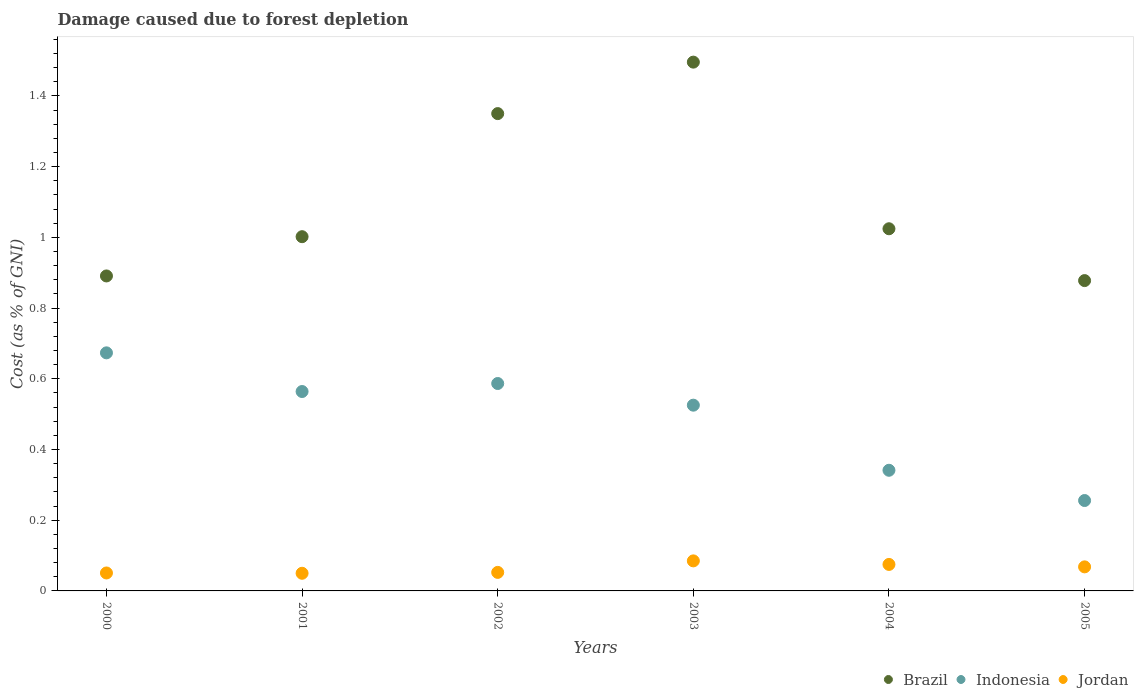How many different coloured dotlines are there?
Keep it short and to the point. 3. What is the cost of damage caused due to forest depletion in Jordan in 2005?
Your answer should be compact. 0.07. Across all years, what is the maximum cost of damage caused due to forest depletion in Jordan?
Provide a short and direct response. 0.08. Across all years, what is the minimum cost of damage caused due to forest depletion in Jordan?
Give a very brief answer. 0.05. In which year was the cost of damage caused due to forest depletion in Indonesia minimum?
Give a very brief answer. 2005. What is the total cost of damage caused due to forest depletion in Brazil in the graph?
Your answer should be very brief. 6.64. What is the difference between the cost of damage caused due to forest depletion in Jordan in 2004 and that in 2005?
Offer a terse response. 0.01. What is the difference between the cost of damage caused due to forest depletion in Indonesia in 2003 and the cost of damage caused due to forest depletion in Jordan in 2005?
Provide a short and direct response. 0.46. What is the average cost of damage caused due to forest depletion in Jordan per year?
Make the answer very short. 0.06. In the year 2002, what is the difference between the cost of damage caused due to forest depletion in Brazil and cost of damage caused due to forest depletion in Jordan?
Give a very brief answer. 1.3. In how many years, is the cost of damage caused due to forest depletion in Jordan greater than 0.24000000000000002 %?
Provide a short and direct response. 0. What is the ratio of the cost of damage caused due to forest depletion in Brazil in 2000 to that in 2004?
Your answer should be very brief. 0.87. Is the cost of damage caused due to forest depletion in Brazil in 2000 less than that in 2004?
Provide a succinct answer. Yes. Is the difference between the cost of damage caused due to forest depletion in Brazil in 2001 and 2002 greater than the difference between the cost of damage caused due to forest depletion in Jordan in 2001 and 2002?
Provide a succinct answer. No. What is the difference between the highest and the second highest cost of damage caused due to forest depletion in Brazil?
Provide a short and direct response. 0.15. What is the difference between the highest and the lowest cost of damage caused due to forest depletion in Brazil?
Offer a terse response. 0.62. Is it the case that in every year, the sum of the cost of damage caused due to forest depletion in Brazil and cost of damage caused due to forest depletion in Indonesia  is greater than the cost of damage caused due to forest depletion in Jordan?
Offer a terse response. Yes. How many dotlines are there?
Provide a succinct answer. 3. Are the values on the major ticks of Y-axis written in scientific E-notation?
Keep it short and to the point. No. What is the title of the graph?
Offer a terse response. Damage caused due to forest depletion. Does "Small states" appear as one of the legend labels in the graph?
Offer a terse response. No. What is the label or title of the X-axis?
Keep it short and to the point. Years. What is the label or title of the Y-axis?
Offer a very short reply. Cost (as % of GNI). What is the Cost (as % of GNI) of Brazil in 2000?
Your answer should be compact. 0.89. What is the Cost (as % of GNI) in Indonesia in 2000?
Your response must be concise. 0.67. What is the Cost (as % of GNI) of Jordan in 2000?
Your answer should be compact. 0.05. What is the Cost (as % of GNI) of Brazil in 2001?
Ensure brevity in your answer.  1. What is the Cost (as % of GNI) in Indonesia in 2001?
Offer a very short reply. 0.56. What is the Cost (as % of GNI) in Jordan in 2001?
Give a very brief answer. 0.05. What is the Cost (as % of GNI) in Brazil in 2002?
Ensure brevity in your answer.  1.35. What is the Cost (as % of GNI) in Indonesia in 2002?
Offer a very short reply. 0.59. What is the Cost (as % of GNI) of Jordan in 2002?
Offer a terse response. 0.05. What is the Cost (as % of GNI) in Brazil in 2003?
Offer a terse response. 1.5. What is the Cost (as % of GNI) of Indonesia in 2003?
Ensure brevity in your answer.  0.53. What is the Cost (as % of GNI) of Jordan in 2003?
Provide a short and direct response. 0.08. What is the Cost (as % of GNI) in Brazil in 2004?
Make the answer very short. 1.02. What is the Cost (as % of GNI) of Indonesia in 2004?
Make the answer very short. 0.34. What is the Cost (as % of GNI) of Jordan in 2004?
Offer a very short reply. 0.07. What is the Cost (as % of GNI) in Brazil in 2005?
Keep it short and to the point. 0.88. What is the Cost (as % of GNI) of Indonesia in 2005?
Ensure brevity in your answer.  0.26. What is the Cost (as % of GNI) of Jordan in 2005?
Give a very brief answer. 0.07. Across all years, what is the maximum Cost (as % of GNI) of Brazil?
Provide a succinct answer. 1.5. Across all years, what is the maximum Cost (as % of GNI) in Indonesia?
Your answer should be very brief. 0.67. Across all years, what is the maximum Cost (as % of GNI) in Jordan?
Provide a succinct answer. 0.08. Across all years, what is the minimum Cost (as % of GNI) of Brazil?
Provide a short and direct response. 0.88. Across all years, what is the minimum Cost (as % of GNI) in Indonesia?
Offer a very short reply. 0.26. Across all years, what is the minimum Cost (as % of GNI) of Jordan?
Provide a short and direct response. 0.05. What is the total Cost (as % of GNI) of Brazil in the graph?
Your response must be concise. 6.64. What is the total Cost (as % of GNI) of Indonesia in the graph?
Give a very brief answer. 2.95. What is the total Cost (as % of GNI) in Jordan in the graph?
Make the answer very short. 0.38. What is the difference between the Cost (as % of GNI) of Brazil in 2000 and that in 2001?
Keep it short and to the point. -0.11. What is the difference between the Cost (as % of GNI) of Indonesia in 2000 and that in 2001?
Offer a very short reply. 0.11. What is the difference between the Cost (as % of GNI) of Jordan in 2000 and that in 2001?
Offer a very short reply. 0. What is the difference between the Cost (as % of GNI) of Brazil in 2000 and that in 2002?
Offer a very short reply. -0.46. What is the difference between the Cost (as % of GNI) in Indonesia in 2000 and that in 2002?
Your response must be concise. 0.09. What is the difference between the Cost (as % of GNI) of Jordan in 2000 and that in 2002?
Give a very brief answer. -0. What is the difference between the Cost (as % of GNI) in Brazil in 2000 and that in 2003?
Your answer should be very brief. -0.6. What is the difference between the Cost (as % of GNI) of Indonesia in 2000 and that in 2003?
Your answer should be very brief. 0.15. What is the difference between the Cost (as % of GNI) of Jordan in 2000 and that in 2003?
Your answer should be compact. -0.03. What is the difference between the Cost (as % of GNI) of Brazil in 2000 and that in 2004?
Provide a short and direct response. -0.13. What is the difference between the Cost (as % of GNI) in Indonesia in 2000 and that in 2004?
Give a very brief answer. 0.33. What is the difference between the Cost (as % of GNI) of Jordan in 2000 and that in 2004?
Give a very brief answer. -0.02. What is the difference between the Cost (as % of GNI) of Brazil in 2000 and that in 2005?
Make the answer very short. 0.01. What is the difference between the Cost (as % of GNI) of Indonesia in 2000 and that in 2005?
Your answer should be compact. 0.42. What is the difference between the Cost (as % of GNI) of Jordan in 2000 and that in 2005?
Your response must be concise. -0.02. What is the difference between the Cost (as % of GNI) in Brazil in 2001 and that in 2002?
Make the answer very short. -0.35. What is the difference between the Cost (as % of GNI) of Indonesia in 2001 and that in 2002?
Offer a very short reply. -0.02. What is the difference between the Cost (as % of GNI) of Jordan in 2001 and that in 2002?
Give a very brief answer. -0. What is the difference between the Cost (as % of GNI) in Brazil in 2001 and that in 2003?
Offer a terse response. -0.49. What is the difference between the Cost (as % of GNI) of Indonesia in 2001 and that in 2003?
Your answer should be very brief. 0.04. What is the difference between the Cost (as % of GNI) in Jordan in 2001 and that in 2003?
Offer a very short reply. -0.04. What is the difference between the Cost (as % of GNI) of Brazil in 2001 and that in 2004?
Offer a terse response. -0.02. What is the difference between the Cost (as % of GNI) of Indonesia in 2001 and that in 2004?
Provide a succinct answer. 0.22. What is the difference between the Cost (as % of GNI) in Jordan in 2001 and that in 2004?
Provide a short and direct response. -0.03. What is the difference between the Cost (as % of GNI) of Brazil in 2001 and that in 2005?
Your answer should be very brief. 0.12. What is the difference between the Cost (as % of GNI) in Indonesia in 2001 and that in 2005?
Make the answer very short. 0.31. What is the difference between the Cost (as % of GNI) in Jordan in 2001 and that in 2005?
Ensure brevity in your answer.  -0.02. What is the difference between the Cost (as % of GNI) in Brazil in 2002 and that in 2003?
Give a very brief answer. -0.15. What is the difference between the Cost (as % of GNI) of Indonesia in 2002 and that in 2003?
Provide a short and direct response. 0.06. What is the difference between the Cost (as % of GNI) in Jordan in 2002 and that in 2003?
Your response must be concise. -0.03. What is the difference between the Cost (as % of GNI) of Brazil in 2002 and that in 2004?
Give a very brief answer. 0.33. What is the difference between the Cost (as % of GNI) of Indonesia in 2002 and that in 2004?
Offer a very short reply. 0.25. What is the difference between the Cost (as % of GNI) of Jordan in 2002 and that in 2004?
Make the answer very short. -0.02. What is the difference between the Cost (as % of GNI) in Brazil in 2002 and that in 2005?
Offer a terse response. 0.47. What is the difference between the Cost (as % of GNI) in Indonesia in 2002 and that in 2005?
Ensure brevity in your answer.  0.33. What is the difference between the Cost (as % of GNI) in Jordan in 2002 and that in 2005?
Your response must be concise. -0.02. What is the difference between the Cost (as % of GNI) in Brazil in 2003 and that in 2004?
Provide a succinct answer. 0.47. What is the difference between the Cost (as % of GNI) of Indonesia in 2003 and that in 2004?
Make the answer very short. 0.18. What is the difference between the Cost (as % of GNI) in Jordan in 2003 and that in 2004?
Ensure brevity in your answer.  0.01. What is the difference between the Cost (as % of GNI) of Brazil in 2003 and that in 2005?
Make the answer very short. 0.62. What is the difference between the Cost (as % of GNI) in Indonesia in 2003 and that in 2005?
Your answer should be compact. 0.27. What is the difference between the Cost (as % of GNI) in Jordan in 2003 and that in 2005?
Provide a succinct answer. 0.02. What is the difference between the Cost (as % of GNI) of Brazil in 2004 and that in 2005?
Ensure brevity in your answer.  0.15. What is the difference between the Cost (as % of GNI) in Indonesia in 2004 and that in 2005?
Keep it short and to the point. 0.09. What is the difference between the Cost (as % of GNI) in Jordan in 2004 and that in 2005?
Provide a succinct answer. 0.01. What is the difference between the Cost (as % of GNI) in Brazil in 2000 and the Cost (as % of GNI) in Indonesia in 2001?
Your response must be concise. 0.33. What is the difference between the Cost (as % of GNI) of Brazil in 2000 and the Cost (as % of GNI) of Jordan in 2001?
Provide a succinct answer. 0.84. What is the difference between the Cost (as % of GNI) in Indonesia in 2000 and the Cost (as % of GNI) in Jordan in 2001?
Keep it short and to the point. 0.62. What is the difference between the Cost (as % of GNI) in Brazil in 2000 and the Cost (as % of GNI) in Indonesia in 2002?
Provide a succinct answer. 0.3. What is the difference between the Cost (as % of GNI) of Brazil in 2000 and the Cost (as % of GNI) of Jordan in 2002?
Provide a short and direct response. 0.84. What is the difference between the Cost (as % of GNI) in Indonesia in 2000 and the Cost (as % of GNI) in Jordan in 2002?
Make the answer very short. 0.62. What is the difference between the Cost (as % of GNI) in Brazil in 2000 and the Cost (as % of GNI) in Indonesia in 2003?
Make the answer very short. 0.37. What is the difference between the Cost (as % of GNI) in Brazil in 2000 and the Cost (as % of GNI) in Jordan in 2003?
Make the answer very short. 0.81. What is the difference between the Cost (as % of GNI) in Indonesia in 2000 and the Cost (as % of GNI) in Jordan in 2003?
Offer a very short reply. 0.59. What is the difference between the Cost (as % of GNI) in Brazil in 2000 and the Cost (as % of GNI) in Indonesia in 2004?
Offer a terse response. 0.55. What is the difference between the Cost (as % of GNI) of Brazil in 2000 and the Cost (as % of GNI) of Jordan in 2004?
Keep it short and to the point. 0.82. What is the difference between the Cost (as % of GNI) of Indonesia in 2000 and the Cost (as % of GNI) of Jordan in 2004?
Offer a terse response. 0.6. What is the difference between the Cost (as % of GNI) of Brazil in 2000 and the Cost (as % of GNI) of Indonesia in 2005?
Your response must be concise. 0.64. What is the difference between the Cost (as % of GNI) in Brazil in 2000 and the Cost (as % of GNI) in Jordan in 2005?
Provide a short and direct response. 0.82. What is the difference between the Cost (as % of GNI) of Indonesia in 2000 and the Cost (as % of GNI) of Jordan in 2005?
Keep it short and to the point. 0.61. What is the difference between the Cost (as % of GNI) in Brazil in 2001 and the Cost (as % of GNI) in Indonesia in 2002?
Offer a very short reply. 0.42. What is the difference between the Cost (as % of GNI) of Brazil in 2001 and the Cost (as % of GNI) of Jordan in 2002?
Give a very brief answer. 0.95. What is the difference between the Cost (as % of GNI) of Indonesia in 2001 and the Cost (as % of GNI) of Jordan in 2002?
Give a very brief answer. 0.51. What is the difference between the Cost (as % of GNI) in Brazil in 2001 and the Cost (as % of GNI) in Indonesia in 2003?
Provide a short and direct response. 0.48. What is the difference between the Cost (as % of GNI) of Brazil in 2001 and the Cost (as % of GNI) of Jordan in 2003?
Your response must be concise. 0.92. What is the difference between the Cost (as % of GNI) of Indonesia in 2001 and the Cost (as % of GNI) of Jordan in 2003?
Offer a very short reply. 0.48. What is the difference between the Cost (as % of GNI) of Brazil in 2001 and the Cost (as % of GNI) of Indonesia in 2004?
Provide a short and direct response. 0.66. What is the difference between the Cost (as % of GNI) of Brazil in 2001 and the Cost (as % of GNI) of Jordan in 2004?
Your response must be concise. 0.93. What is the difference between the Cost (as % of GNI) in Indonesia in 2001 and the Cost (as % of GNI) in Jordan in 2004?
Your answer should be very brief. 0.49. What is the difference between the Cost (as % of GNI) of Brazil in 2001 and the Cost (as % of GNI) of Indonesia in 2005?
Your response must be concise. 0.75. What is the difference between the Cost (as % of GNI) in Brazil in 2001 and the Cost (as % of GNI) in Jordan in 2005?
Your response must be concise. 0.93. What is the difference between the Cost (as % of GNI) of Indonesia in 2001 and the Cost (as % of GNI) of Jordan in 2005?
Provide a short and direct response. 0.5. What is the difference between the Cost (as % of GNI) of Brazil in 2002 and the Cost (as % of GNI) of Indonesia in 2003?
Keep it short and to the point. 0.82. What is the difference between the Cost (as % of GNI) of Brazil in 2002 and the Cost (as % of GNI) of Jordan in 2003?
Ensure brevity in your answer.  1.26. What is the difference between the Cost (as % of GNI) in Indonesia in 2002 and the Cost (as % of GNI) in Jordan in 2003?
Ensure brevity in your answer.  0.5. What is the difference between the Cost (as % of GNI) in Brazil in 2002 and the Cost (as % of GNI) in Indonesia in 2004?
Provide a short and direct response. 1.01. What is the difference between the Cost (as % of GNI) in Brazil in 2002 and the Cost (as % of GNI) in Jordan in 2004?
Give a very brief answer. 1.27. What is the difference between the Cost (as % of GNI) of Indonesia in 2002 and the Cost (as % of GNI) of Jordan in 2004?
Ensure brevity in your answer.  0.51. What is the difference between the Cost (as % of GNI) in Brazil in 2002 and the Cost (as % of GNI) in Indonesia in 2005?
Make the answer very short. 1.09. What is the difference between the Cost (as % of GNI) of Brazil in 2002 and the Cost (as % of GNI) of Jordan in 2005?
Your answer should be very brief. 1.28. What is the difference between the Cost (as % of GNI) in Indonesia in 2002 and the Cost (as % of GNI) in Jordan in 2005?
Your answer should be compact. 0.52. What is the difference between the Cost (as % of GNI) in Brazil in 2003 and the Cost (as % of GNI) in Indonesia in 2004?
Make the answer very short. 1.15. What is the difference between the Cost (as % of GNI) of Brazil in 2003 and the Cost (as % of GNI) of Jordan in 2004?
Offer a very short reply. 1.42. What is the difference between the Cost (as % of GNI) in Indonesia in 2003 and the Cost (as % of GNI) in Jordan in 2004?
Provide a short and direct response. 0.45. What is the difference between the Cost (as % of GNI) of Brazil in 2003 and the Cost (as % of GNI) of Indonesia in 2005?
Give a very brief answer. 1.24. What is the difference between the Cost (as % of GNI) in Brazil in 2003 and the Cost (as % of GNI) in Jordan in 2005?
Offer a terse response. 1.43. What is the difference between the Cost (as % of GNI) in Indonesia in 2003 and the Cost (as % of GNI) in Jordan in 2005?
Keep it short and to the point. 0.46. What is the difference between the Cost (as % of GNI) in Brazil in 2004 and the Cost (as % of GNI) in Indonesia in 2005?
Give a very brief answer. 0.77. What is the difference between the Cost (as % of GNI) of Brazil in 2004 and the Cost (as % of GNI) of Jordan in 2005?
Provide a short and direct response. 0.96. What is the difference between the Cost (as % of GNI) in Indonesia in 2004 and the Cost (as % of GNI) in Jordan in 2005?
Keep it short and to the point. 0.27. What is the average Cost (as % of GNI) in Brazil per year?
Keep it short and to the point. 1.11. What is the average Cost (as % of GNI) of Indonesia per year?
Provide a short and direct response. 0.49. What is the average Cost (as % of GNI) of Jordan per year?
Make the answer very short. 0.06. In the year 2000, what is the difference between the Cost (as % of GNI) in Brazil and Cost (as % of GNI) in Indonesia?
Your answer should be compact. 0.22. In the year 2000, what is the difference between the Cost (as % of GNI) in Brazil and Cost (as % of GNI) in Jordan?
Provide a succinct answer. 0.84. In the year 2000, what is the difference between the Cost (as % of GNI) of Indonesia and Cost (as % of GNI) of Jordan?
Offer a very short reply. 0.62. In the year 2001, what is the difference between the Cost (as % of GNI) in Brazil and Cost (as % of GNI) in Indonesia?
Your answer should be very brief. 0.44. In the year 2001, what is the difference between the Cost (as % of GNI) of Brazil and Cost (as % of GNI) of Jordan?
Make the answer very short. 0.95. In the year 2001, what is the difference between the Cost (as % of GNI) in Indonesia and Cost (as % of GNI) in Jordan?
Keep it short and to the point. 0.51. In the year 2002, what is the difference between the Cost (as % of GNI) of Brazil and Cost (as % of GNI) of Indonesia?
Provide a succinct answer. 0.76. In the year 2002, what is the difference between the Cost (as % of GNI) in Brazil and Cost (as % of GNI) in Jordan?
Your answer should be very brief. 1.3. In the year 2002, what is the difference between the Cost (as % of GNI) in Indonesia and Cost (as % of GNI) in Jordan?
Provide a short and direct response. 0.53. In the year 2003, what is the difference between the Cost (as % of GNI) in Brazil and Cost (as % of GNI) in Indonesia?
Your response must be concise. 0.97. In the year 2003, what is the difference between the Cost (as % of GNI) of Brazil and Cost (as % of GNI) of Jordan?
Your answer should be compact. 1.41. In the year 2003, what is the difference between the Cost (as % of GNI) of Indonesia and Cost (as % of GNI) of Jordan?
Make the answer very short. 0.44. In the year 2004, what is the difference between the Cost (as % of GNI) in Brazil and Cost (as % of GNI) in Indonesia?
Make the answer very short. 0.68. In the year 2004, what is the difference between the Cost (as % of GNI) of Brazil and Cost (as % of GNI) of Jordan?
Your response must be concise. 0.95. In the year 2004, what is the difference between the Cost (as % of GNI) of Indonesia and Cost (as % of GNI) of Jordan?
Provide a short and direct response. 0.27. In the year 2005, what is the difference between the Cost (as % of GNI) in Brazil and Cost (as % of GNI) in Indonesia?
Offer a terse response. 0.62. In the year 2005, what is the difference between the Cost (as % of GNI) in Brazil and Cost (as % of GNI) in Jordan?
Your answer should be very brief. 0.81. In the year 2005, what is the difference between the Cost (as % of GNI) of Indonesia and Cost (as % of GNI) of Jordan?
Your answer should be compact. 0.19. What is the ratio of the Cost (as % of GNI) in Brazil in 2000 to that in 2001?
Your answer should be very brief. 0.89. What is the ratio of the Cost (as % of GNI) of Indonesia in 2000 to that in 2001?
Offer a very short reply. 1.19. What is the ratio of the Cost (as % of GNI) of Brazil in 2000 to that in 2002?
Your answer should be compact. 0.66. What is the ratio of the Cost (as % of GNI) in Indonesia in 2000 to that in 2002?
Keep it short and to the point. 1.15. What is the ratio of the Cost (as % of GNI) of Jordan in 2000 to that in 2002?
Your answer should be compact. 0.97. What is the ratio of the Cost (as % of GNI) of Brazil in 2000 to that in 2003?
Keep it short and to the point. 0.6. What is the ratio of the Cost (as % of GNI) of Indonesia in 2000 to that in 2003?
Provide a succinct answer. 1.28. What is the ratio of the Cost (as % of GNI) of Jordan in 2000 to that in 2003?
Ensure brevity in your answer.  0.6. What is the ratio of the Cost (as % of GNI) of Brazil in 2000 to that in 2004?
Make the answer very short. 0.87. What is the ratio of the Cost (as % of GNI) of Indonesia in 2000 to that in 2004?
Keep it short and to the point. 1.97. What is the ratio of the Cost (as % of GNI) in Jordan in 2000 to that in 2004?
Your answer should be very brief. 0.68. What is the ratio of the Cost (as % of GNI) of Brazil in 2000 to that in 2005?
Make the answer very short. 1.01. What is the ratio of the Cost (as % of GNI) in Indonesia in 2000 to that in 2005?
Provide a short and direct response. 2.63. What is the ratio of the Cost (as % of GNI) in Jordan in 2000 to that in 2005?
Your answer should be very brief. 0.75. What is the ratio of the Cost (as % of GNI) in Brazil in 2001 to that in 2002?
Your answer should be compact. 0.74. What is the ratio of the Cost (as % of GNI) of Indonesia in 2001 to that in 2002?
Offer a terse response. 0.96. What is the ratio of the Cost (as % of GNI) in Jordan in 2001 to that in 2002?
Your answer should be compact. 0.95. What is the ratio of the Cost (as % of GNI) in Brazil in 2001 to that in 2003?
Your response must be concise. 0.67. What is the ratio of the Cost (as % of GNI) of Indonesia in 2001 to that in 2003?
Your response must be concise. 1.07. What is the ratio of the Cost (as % of GNI) of Jordan in 2001 to that in 2003?
Your answer should be very brief. 0.59. What is the ratio of the Cost (as % of GNI) of Brazil in 2001 to that in 2004?
Provide a succinct answer. 0.98. What is the ratio of the Cost (as % of GNI) of Indonesia in 2001 to that in 2004?
Your answer should be very brief. 1.65. What is the ratio of the Cost (as % of GNI) of Jordan in 2001 to that in 2004?
Your response must be concise. 0.67. What is the ratio of the Cost (as % of GNI) of Brazil in 2001 to that in 2005?
Offer a very short reply. 1.14. What is the ratio of the Cost (as % of GNI) of Indonesia in 2001 to that in 2005?
Your answer should be compact. 2.21. What is the ratio of the Cost (as % of GNI) in Jordan in 2001 to that in 2005?
Offer a terse response. 0.73. What is the ratio of the Cost (as % of GNI) of Brazil in 2002 to that in 2003?
Your answer should be very brief. 0.9. What is the ratio of the Cost (as % of GNI) in Indonesia in 2002 to that in 2003?
Provide a short and direct response. 1.12. What is the ratio of the Cost (as % of GNI) in Jordan in 2002 to that in 2003?
Give a very brief answer. 0.62. What is the ratio of the Cost (as % of GNI) in Brazil in 2002 to that in 2004?
Ensure brevity in your answer.  1.32. What is the ratio of the Cost (as % of GNI) in Indonesia in 2002 to that in 2004?
Your answer should be very brief. 1.72. What is the ratio of the Cost (as % of GNI) of Jordan in 2002 to that in 2004?
Keep it short and to the point. 0.7. What is the ratio of the Cost (as % of GNI) in Brazil in 2002 to that in 2005?
Offer a terse response. 1.54. What is the ratio of the Cost (as % of GNI) in Indonesia in 2002 to that in 2005?
Provide a short and direct response. 2.29. What is the ratio of the Cost (as % of GNI) of Jordan in 2002 to that in 2005?
Make the answer very short. 0.77. What is the ratio of the Cost (as % of GNI) of Brazil in 2003 to that in 2004?
Offer a terse response. 1.46. What is the ratio of the Cost (as % of GNI) in Indonesia in 2003 to that in 2004?
Make the answer very short. 1.54. What is the ratio of the Cost (as % of GNI) of Jordan in 2003 to that in 2004?
Your answer should be very brief. 1.13. What is the ratio of the Cost (as % of GNI) in Brazil in 2003 to that in 2005?
Your response must be concise. 1.7. What is the ratio of the Cost (as % of GNI) of Indonesia in 2003 to that in 2005?
Offer a terse response. 2.05. What is the ratio of the Cost (as % of GNI) in Jordan in 2003 to that in 2005?
Your response must be concise. 1.25. What is the ratio of the Cost (as % of GNI) in Brazil in 2004 to that in 2005?
Your answer should be very brief. 1.17. What is the ratio of the Cost (as % of GNI) in Indonesia in 2004 to that in 2005?
Provide a succinct answer. 1.33. What is the ratio of the Cost (as % of GNI) in Jordan in 2004 to that in 2005?
Offer a very short reply. 1.1. What is the difference between the highest and the second highest Cost (as % of GNI) of Brazil?
Ensure brevity in your answer.  0.15. What is the difference between the highest and the second highest Cost (as % of GNI) of Indonesia?
Ensure brevity in your answer.  0.09. What is the difference between the highest and the second highest Cost (as % of GNI) of Jordan?
Ensure brevity in your answer.  0.01. What is the difference between the highest and the lowest Cost (as % of GNI) in Brazil?
Your answer should be compact. 0.62. What is the difference between the highest and the lowest Cost (as % of GNI) of Indonesia?
Keep it short and to the point. 0.42. What is the difference between the highest and the lowest Cost (as % of GNI) in Jordan?
Your answer should be compact. 0.04. 